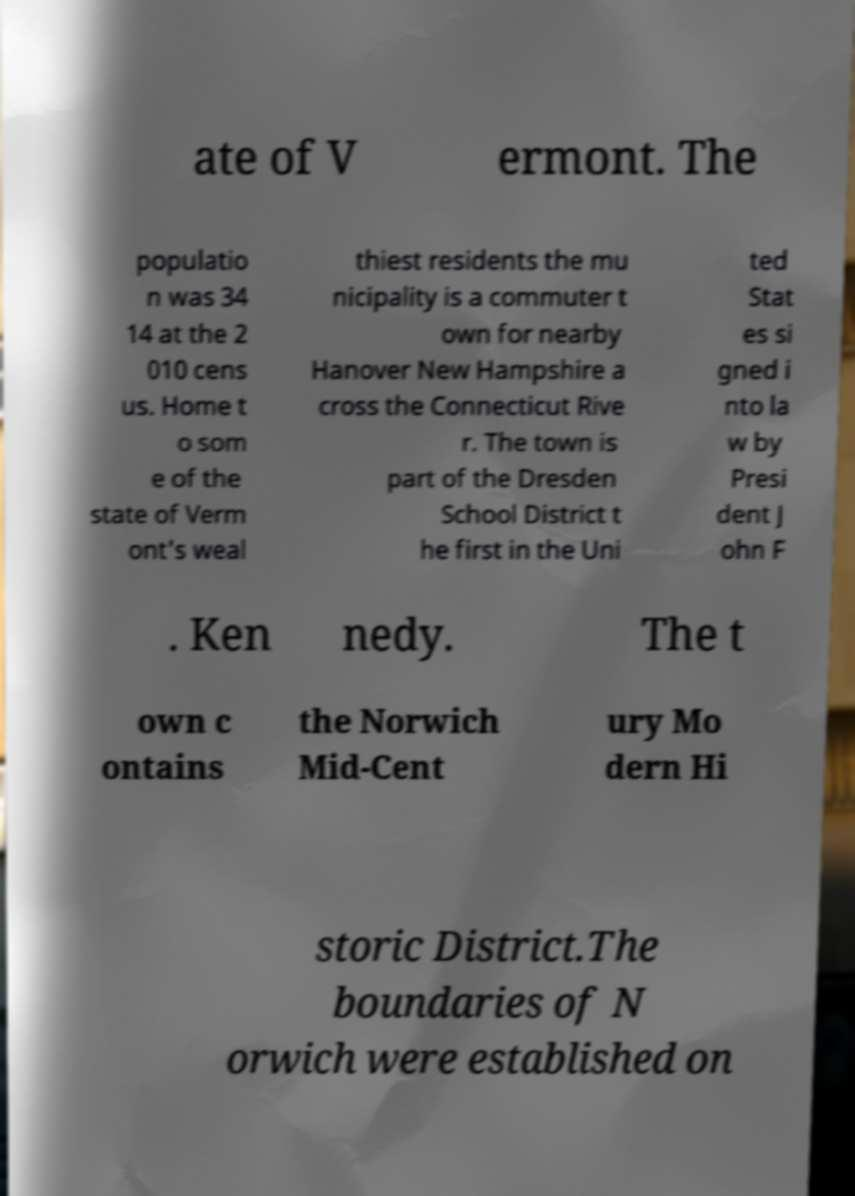Can you read and provide the text displayed in the image?This photo seems to have some interesting text. Can you extract and type it out for me? ate of V ermont. The populatio n was 34 14 at the 2 010 cens us. Home t o som e of the state of Verm ont's weal thiest residents the mu nicipality is a commuter t own for nearby Hanover New Hampshire a cross the Connecticut Rive r. The town is part of the Dresden School District t he first in the Uni ted Stat es si gned i nto la w by Presi dent J ohn F . Ken nedy. The t own c ontains the Norwich Mid-Cent ury Mo dern Hi storic District.The boundaries of N orwich were established on 